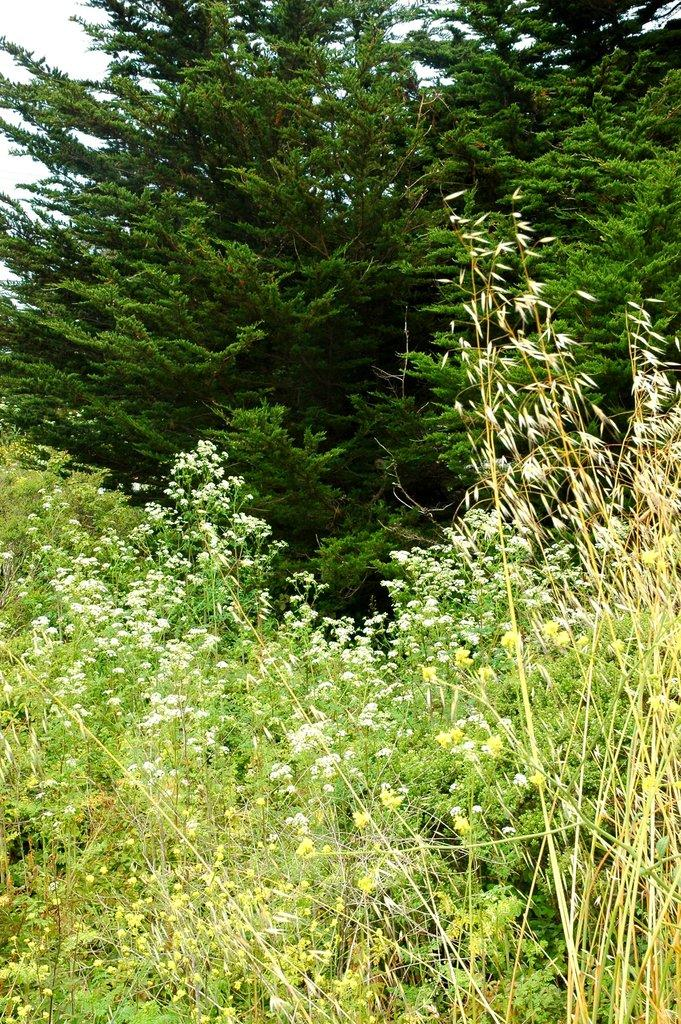What type of vegetation is present at the bottom of the image? There are plants at the bottom of the image. What type of vegetation is present at the top of the image? There are trees at the top of the image. What type of relation can be seen between the plants and the trees in the image? There is no relation between the plants and the trees in the image, as they are simply different types of vegetation located in different parts of the image. Are there any fairies or tramps visible in the image? No, there are no fairies or tramps present in the image. 